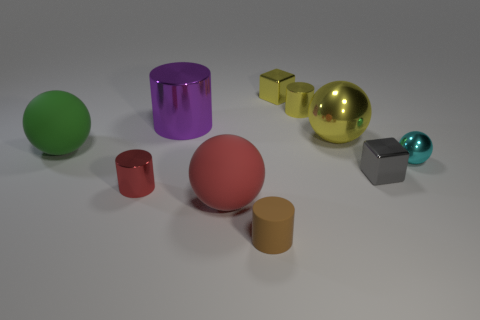Subtract all red metal cylinders. How many cylinders are left? 3 Subtract all purple cylinders. How many cylinders are left? 3 Subtract all spheres. How many objects are left? 6 Subtract all blue balls. Subtract all brown blocks. How many balls are left? 4 Add 2 gray blocks. How many gray blocks are left? 3 Add 8 small yellow cylinders. How many small yellow cylinders exist? 9 Subtract 0 purple balls. How many objects are left? 10 Subtract all red rubber things. Subtract all small red rubber cylinders. How many objects are left? 9 